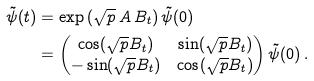Convert formula to latex. <formula><loc_0><loc_0><loc_500><loc_500>\tilde { \psi } ( t ) & = \exp \left ( \sqrt { p } \, A \, B _ { t } \right ) \tilde { \psi } ( 0 ) \\ & = \begin{pmatrix} \cos ( \sqrt { p } B _ { t } ) & \sin ( \sqrt { p } B _ { t } ) \\ - \sin ( \sqrt { p } B _ { t } ) & \cos ( \sqrt { p } B _ { t } ) \end{pmatrix} \tilde { \psi } ( 0 ) \, .</formula> 